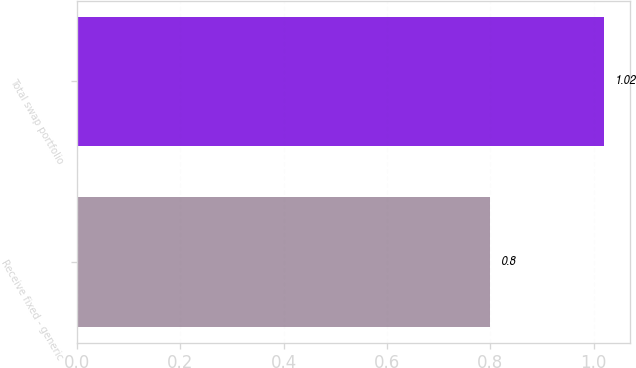<chart> <loc_0><loc_0><loc_500><loc_500><bar_chart><fcel>Receive fixed - generic<fcel>Total swap portfolio<nl><fcel>0.8<fcel>1.02<nl></chart> 